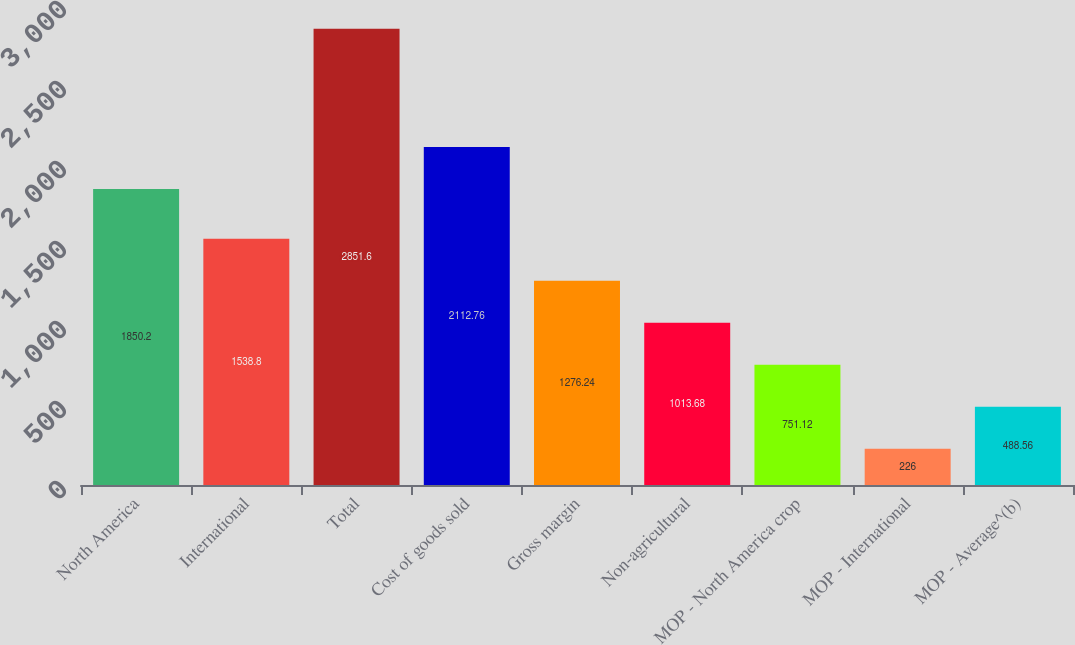Convert chart to OTSL. <chart><loc_0><loc_0><loc_500><loc_500><bar_chart><fcel>North America<fcel>International<fcel>Total<fcel>Cost of goods sold<fcel>Gross margin<fcel>Non-agricultural<fcel>MOP - North America crop<fcel>MOP - International<fcel>MOP - Average^(b)<nl><fcel>1850.2<fcel>1538.8<fcel>2851.6<fcel>2112.76<fcel>1276.24<fcel>1013.68<fcel>751.12<fcel>226<fcel>488.56<nl></chart> 